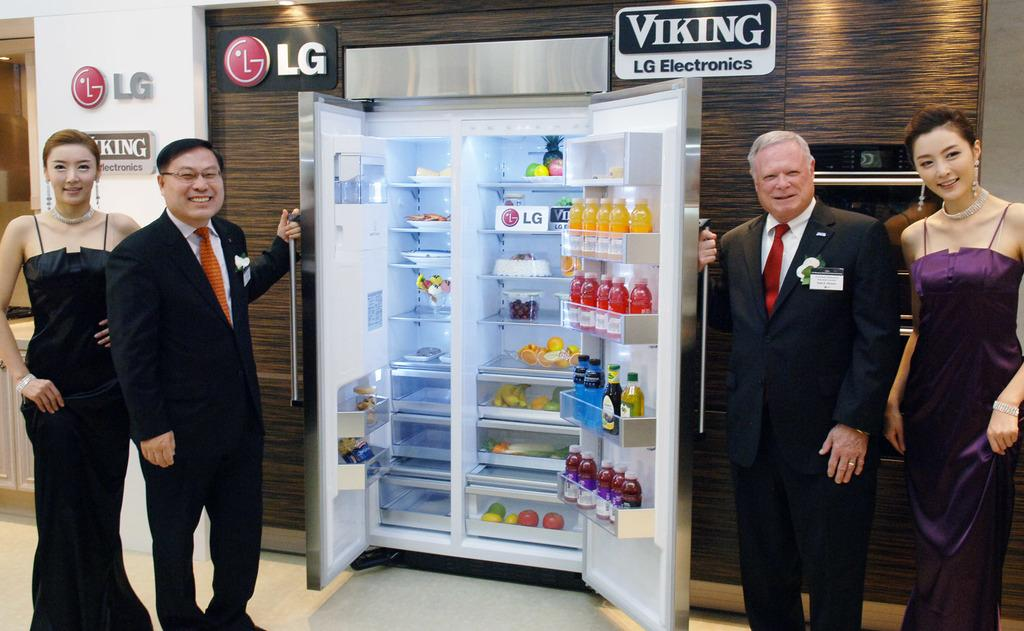Provide a one-sentence caption for the provided image. Several people pose with a refrigerator in an LG Electronics show room. 